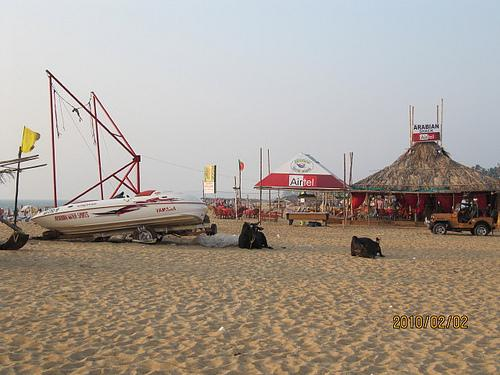What type of geographical feature is located near this area? ocean 